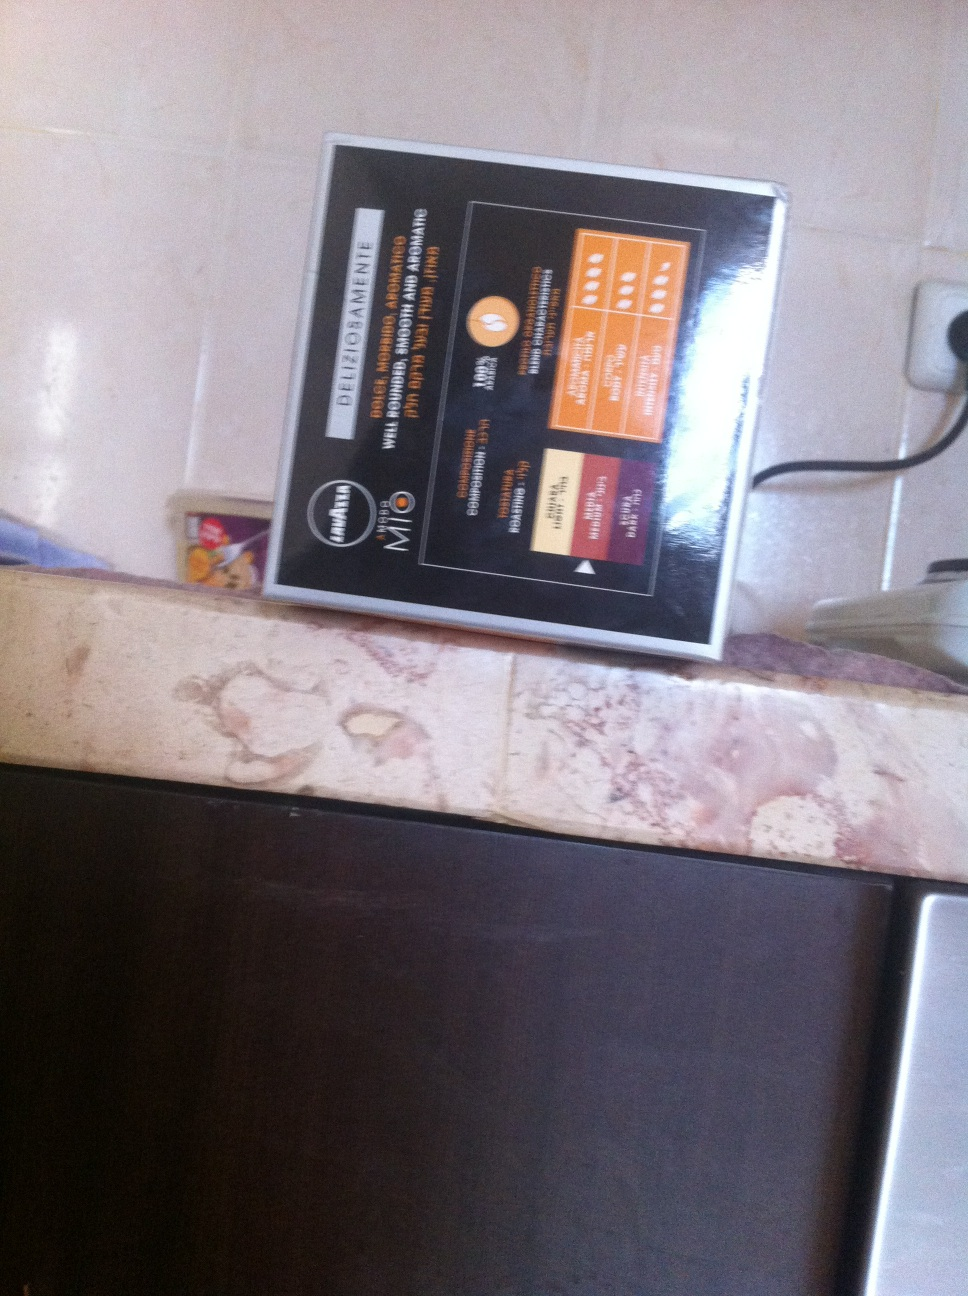What's this? This is an informational booklet or signage placed in a kitchen, providing guidelines and details about diet management. It appears to include various sections on diet tips, potentially for different health scenarios or dietary needs. 